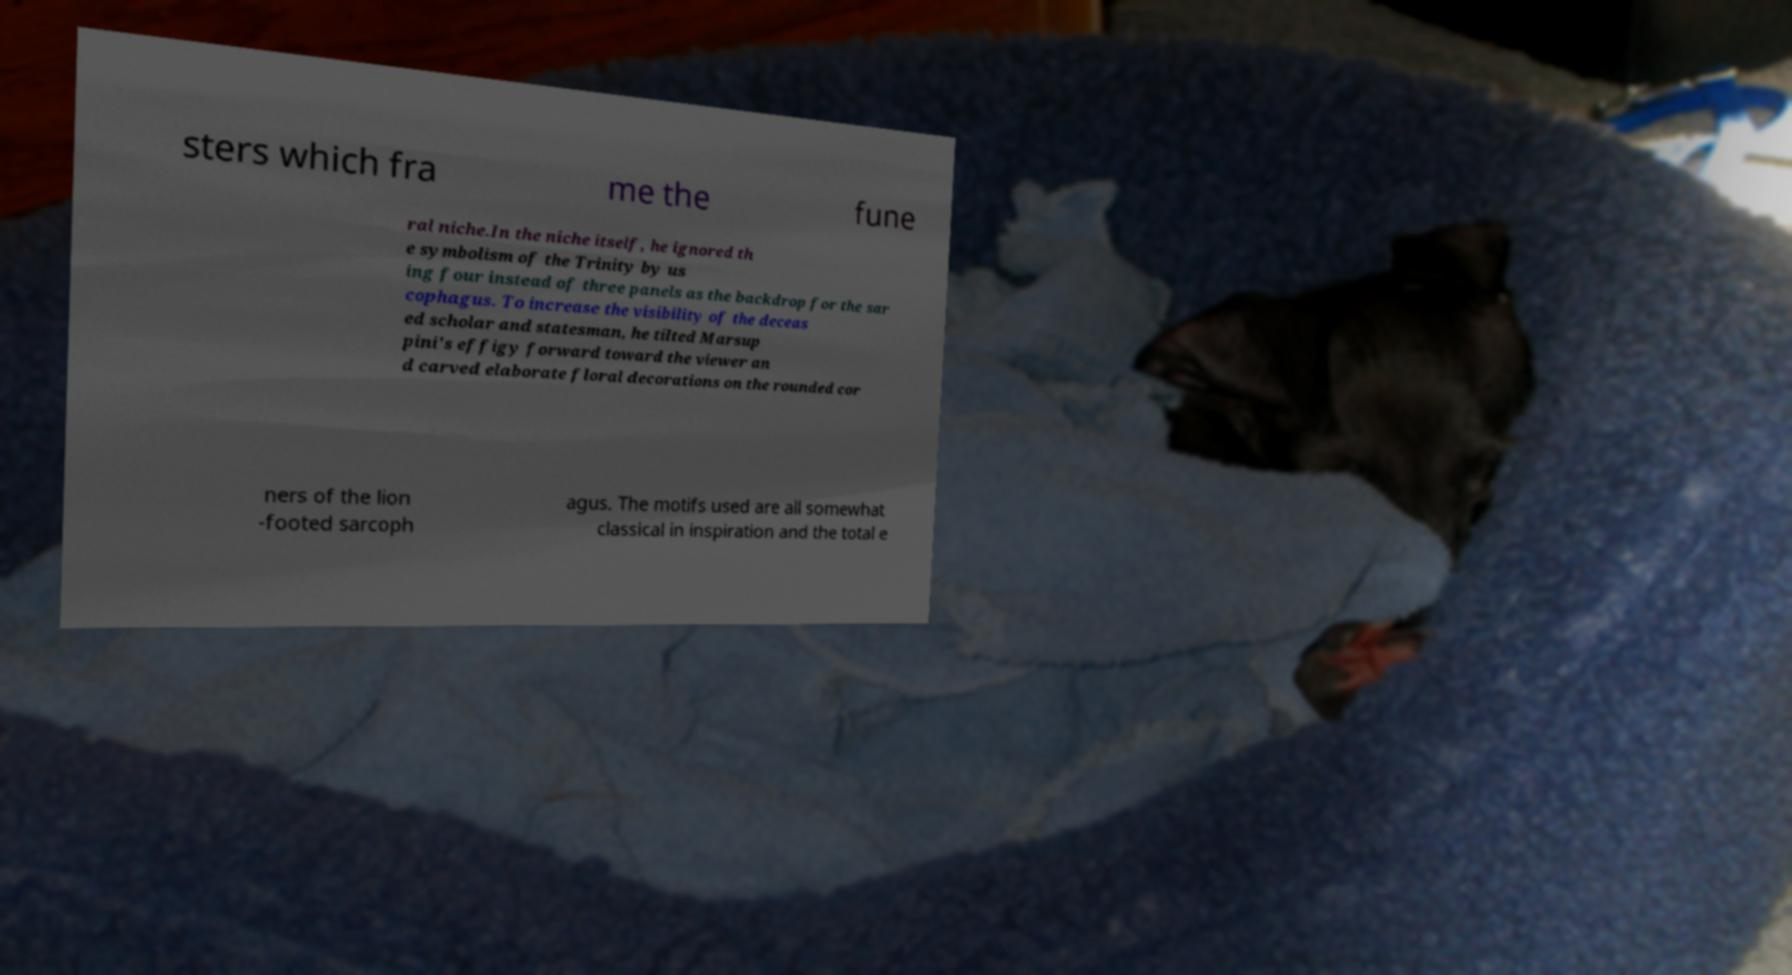Please identify and transcribe the text found in this image. sters which fra me the fune ral niche.In the niche itself, he ignored th e symbolism of the Trinity by us ing four instead of three panels as the backdrop for the sar cophagus. To increase the visibility of the deceas ed scholar and statesman, he tilted Marsup pini's effigy forward toward the viewer an d carved elaborate floral decorations on the rounded cor ners of the lion -footed sarcoph agus. The motifs used are all somewhat classical in inspiration and the total e 